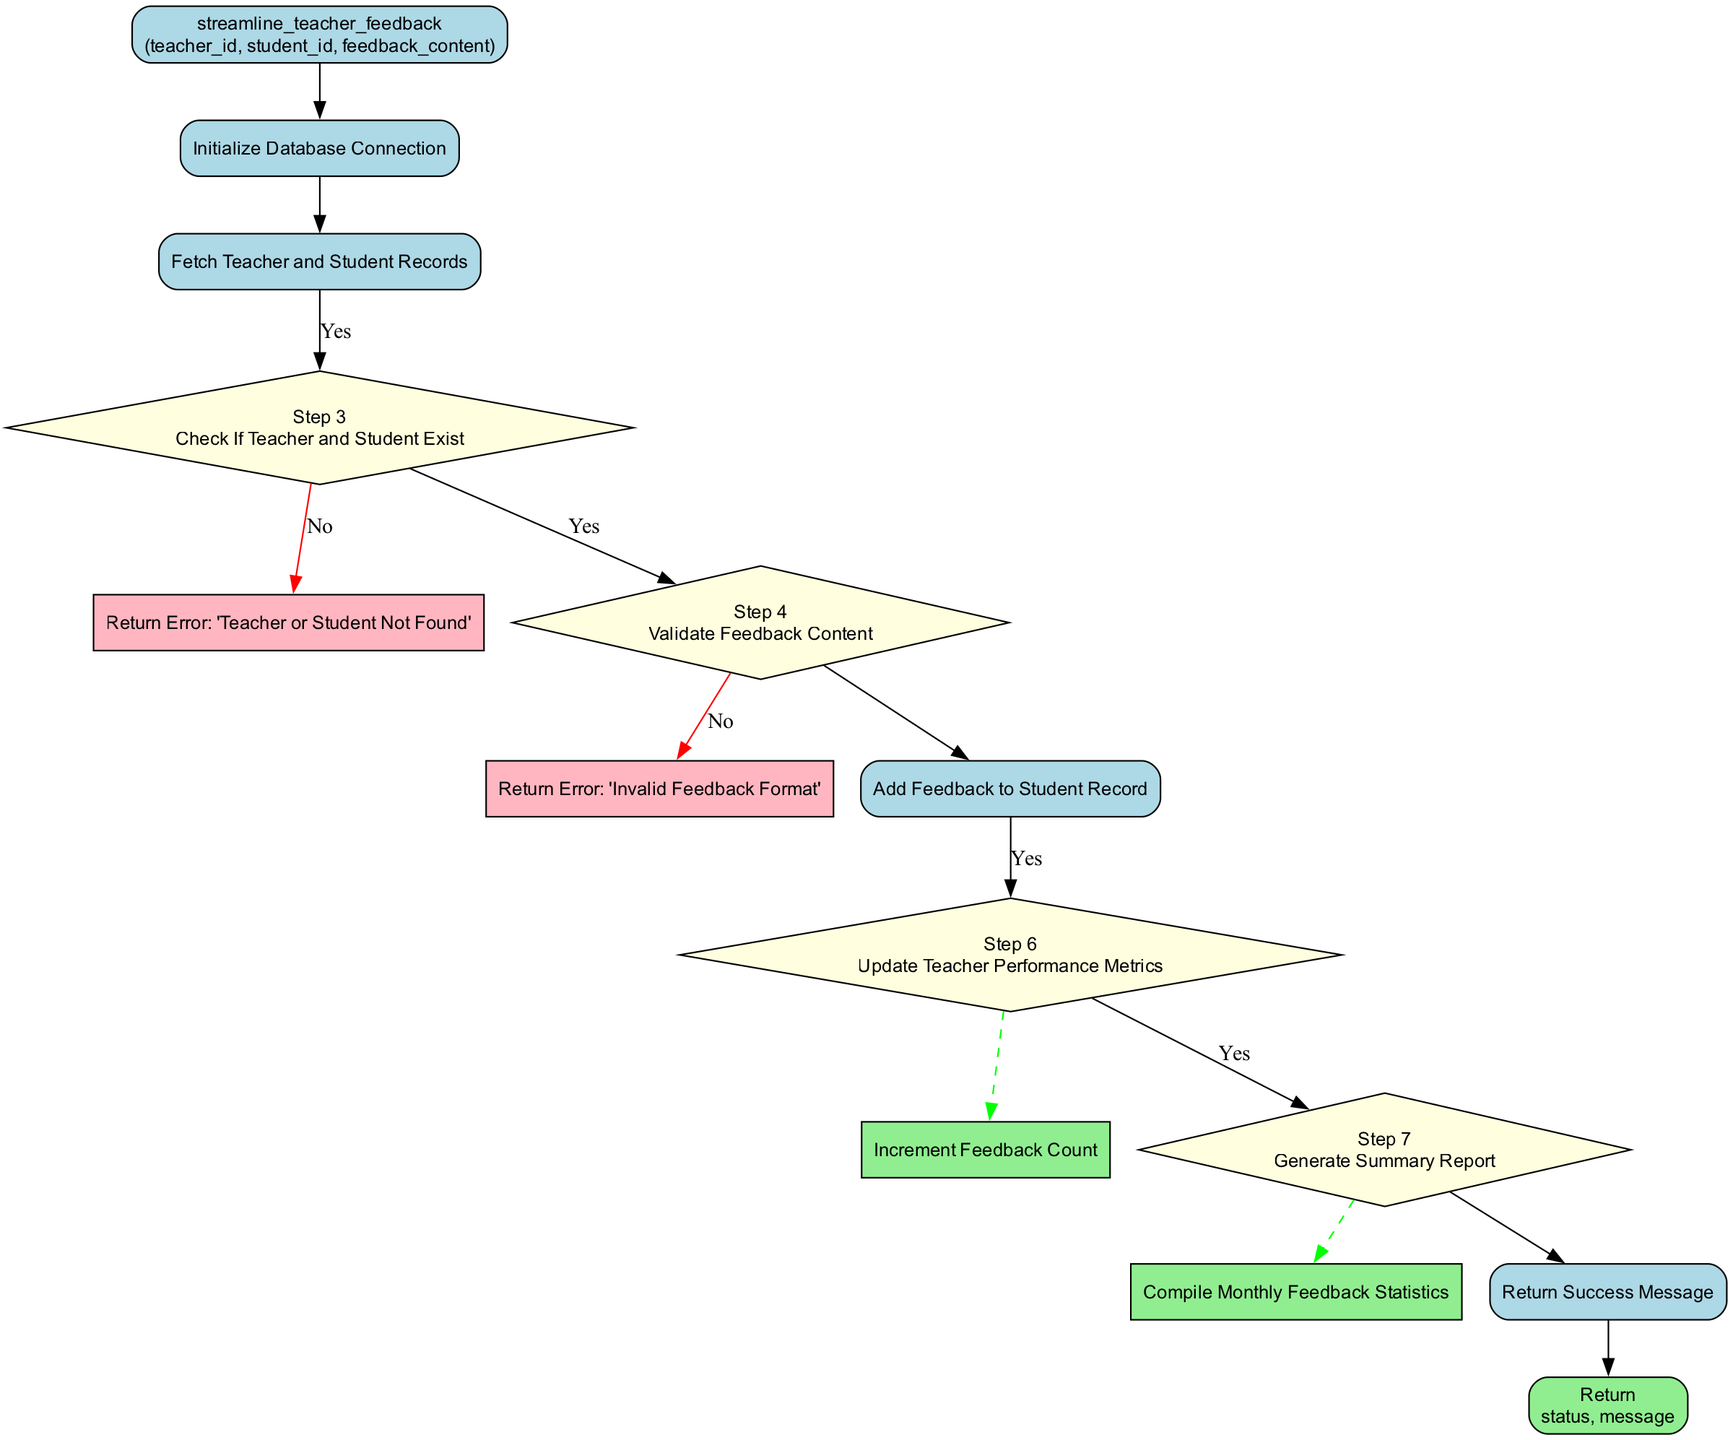What's the first step in the function? The diagram starts with "Initialize Database Connection" as the first step.
Answer: Initialize Database Connection How many steps are there in this flowchart? The flowchart contains a total of eight steps, encompassing initializations, checks, validations, updates, and returns.
Answer: Eight What is the specific error message when the teacher or student is not found? The failure condition in Step 3 states the error message as "Teacher or Student Not Found."
Answer: Teacher or Student Not Found Which step involves updating teacher performance metrics? In Step 6, the process outlines updating teacher performance metrics by incrementing the feedback count.
Answer: Update Teacher Performance Metrics What indicates the validation of feedback content? The flowchart specifies that in Step 4, the validation process occurs, with an error message for invalid content.
Answer: Validate Feedback Content What type of node represents the return output of the function? The return output of the function is represented by a rounded rectangle node at the end of the flowchart.
Answer: Rounded rectangle What is compiled during the generation of the summary report? Step 7 highlights the compilation of monthly feedback statistics in the generation of the summary report.
Answer: Monthly feedback statistics What happens if the feedback content is invalid? If the feedback content is invalid in Step 4, the function will return an error message, specifically "Invalid Feedback Format."
Answer: Invalid Feedback Format How does the flowchart denote a failure condition? The diagram uses a diamond-shaped node that points to a rectangular node colored light pink to denote a failure condition.
Answer: Diamond-shaped node 